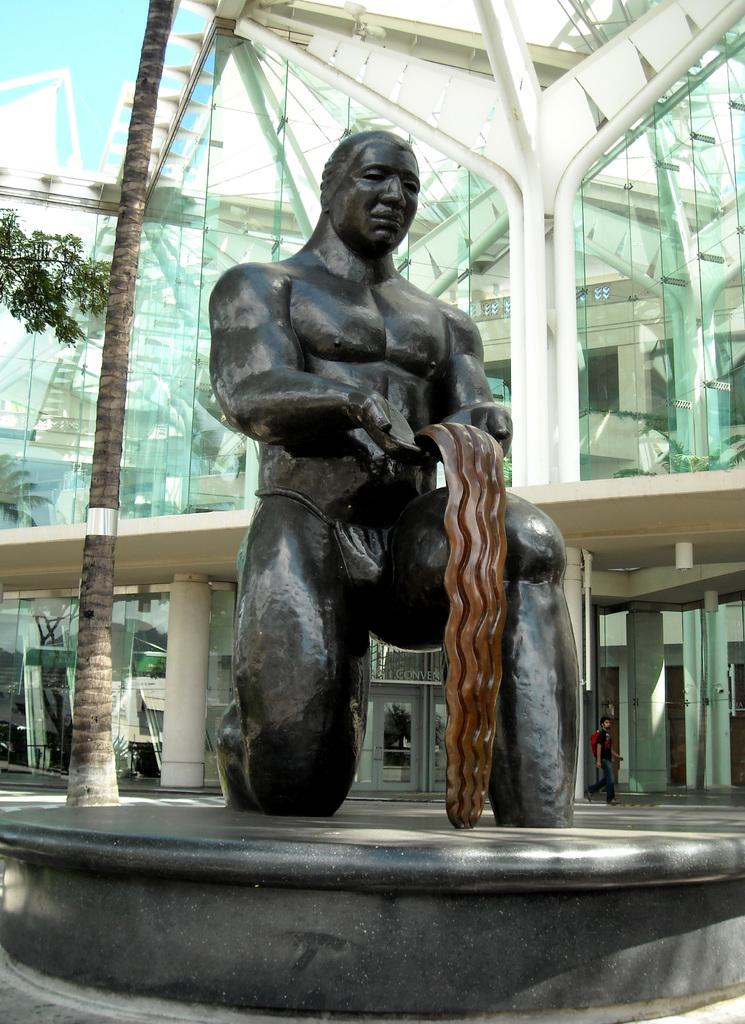What is the main subject on the platform in the image? There is a statue on a platform in the image. What type of natural elements can be seen in the image? There are trees in the image. What type of structure is present in the image? There is a building in the image. What architectural feature is visible in the image? There are pillars in the image. What is the man in the image doing? A man is walking on the ground in the image. What other objects can be seen in the image? There are objects in the image. What can be seen in the background of the image? The sky is visible in the background of the image. How many planes are flying over the statue in the image? There are no planes visible in the image; it only features a statue, trees, a building, pillars, a man walking, and other objects. What type of industry is depicted in the image? There is no industry depicted in the image; it primarily features a statue, trees, a building, pillars, a man walking, and other objects. 